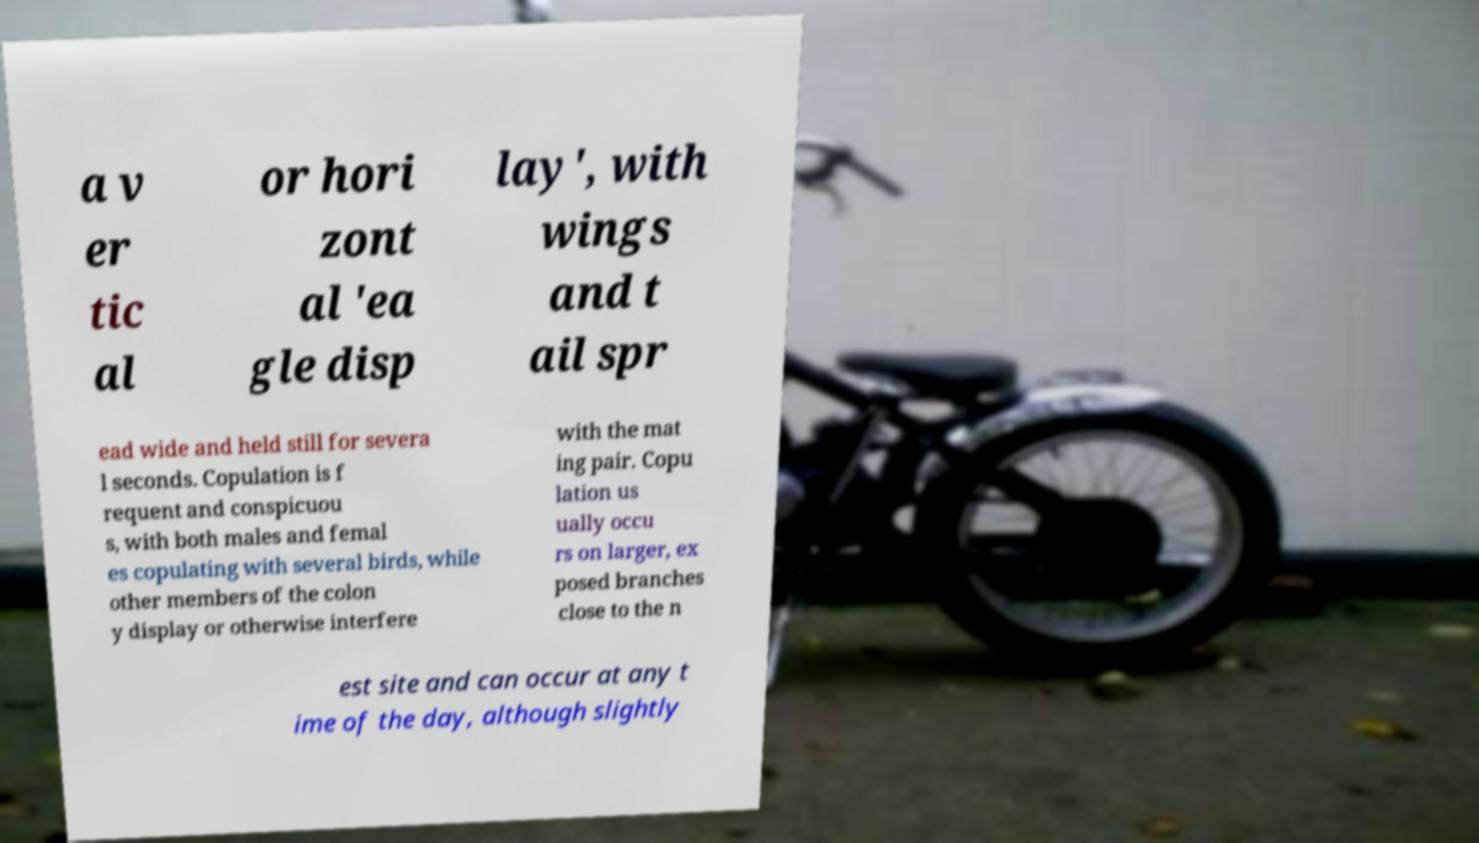For documentation purposes, I need the text within this image transcribed. Could you provide that? a v er tic al or hori zont al 'ea gle disp lay', with wings and t ail spr ead wide and held still for severa l seconds. Copulation is f requent and conspicuou s, with both males and femal es copulating with several birds, while other members of the colon y display or otherwise interfere with the mat ing pair. Copu lation us ually occu rs on larger, ex posed branches close to the n est site and can occur at any t ime of the day, although slightly 